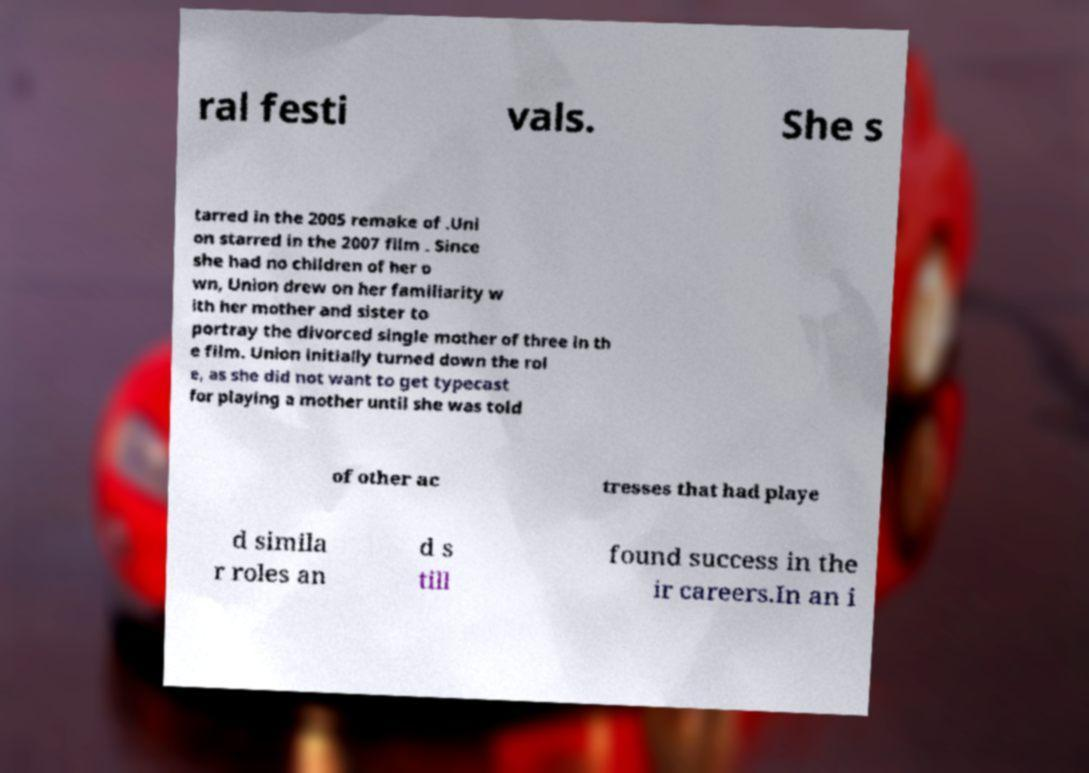Please read and relay the text visible in this image. What does it say? ral festi vals. She s tarred in the 2005 remake of .Uni on starred in the 2007 film . Since she had no children of her o wn, Union drew on her familiarity w ith her mother and sister to portray the divorced single mother of three in th e film. Union initially turned down the rol e, as she did not want to get typecast for playing a mother until she was told of other ac tresses that had playe d simila r roles an d s till found success in the ir careers.In an i 